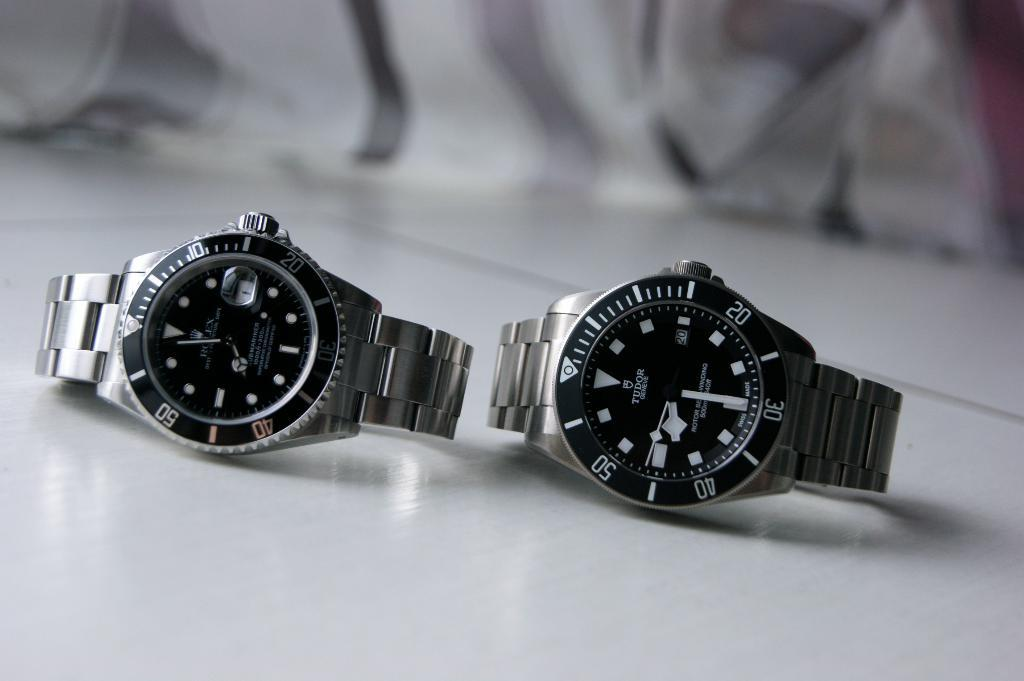<image>
Render a clear and concise summary of the photo. A Rolex and a Tudor watch lay by one another. 